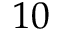Convert formula to latex. <formula><loc_0><loc_0><loc_500><loc_500>1 0</formula> 